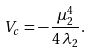<formula> <loc_0><loc_0><loc_500><loc_500>V _ { c } = - \, \frac { \mu _ { 2 } ^ { 4 } } { 4 \, \lambda _ { 2 } } .</formula> 